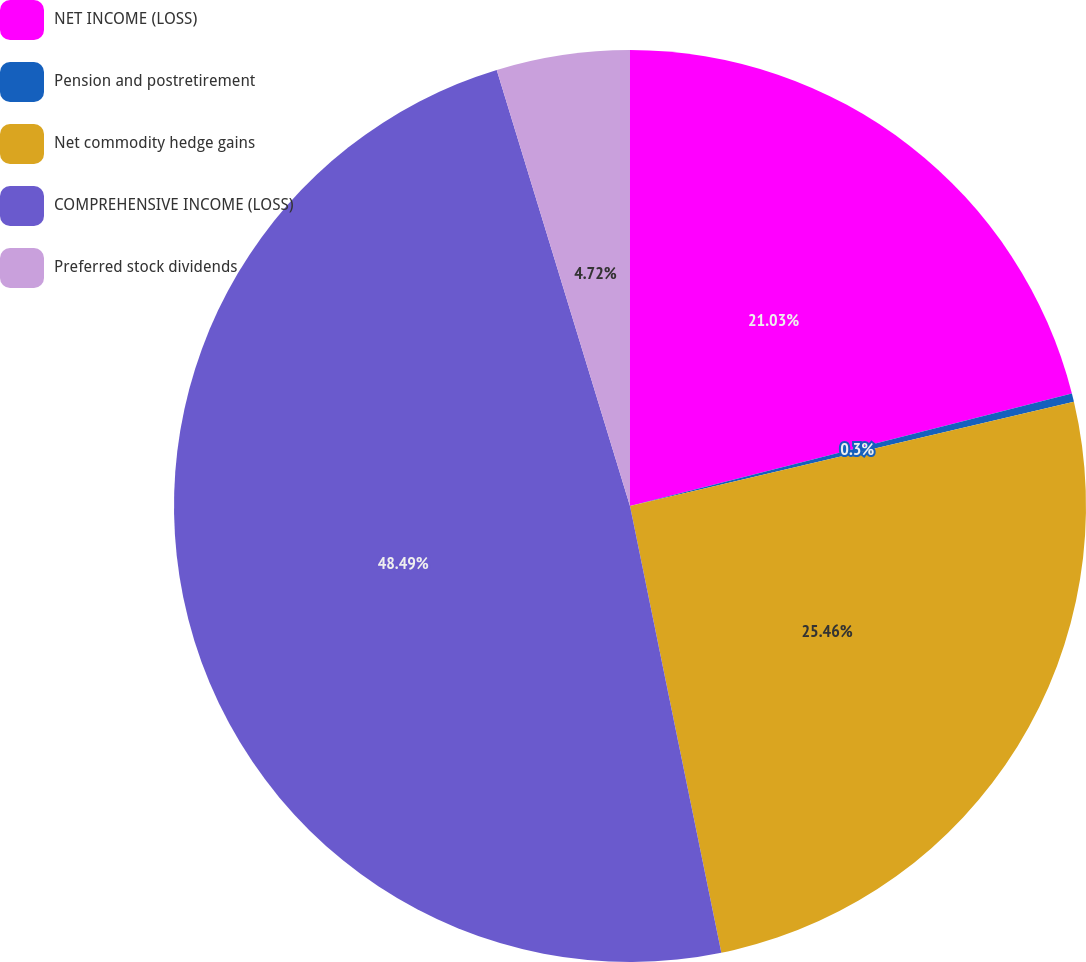Convert chart. <chart><loc_0><loc_0><loc_500><loc_500><pie_chart><fcel>NET INCOME (LOSS)<fcel>Pension and postretirement<fcel>Net commodity hedge gains<fcel>COMPREHENSIVE INCOME (LOSS)<fcel>Preferred stock dividends<nl><fcel>21.03%<fcel>0.3%<fcel>25.46%<fcel>48.49%<fcel>4.72%<nl></chart> 